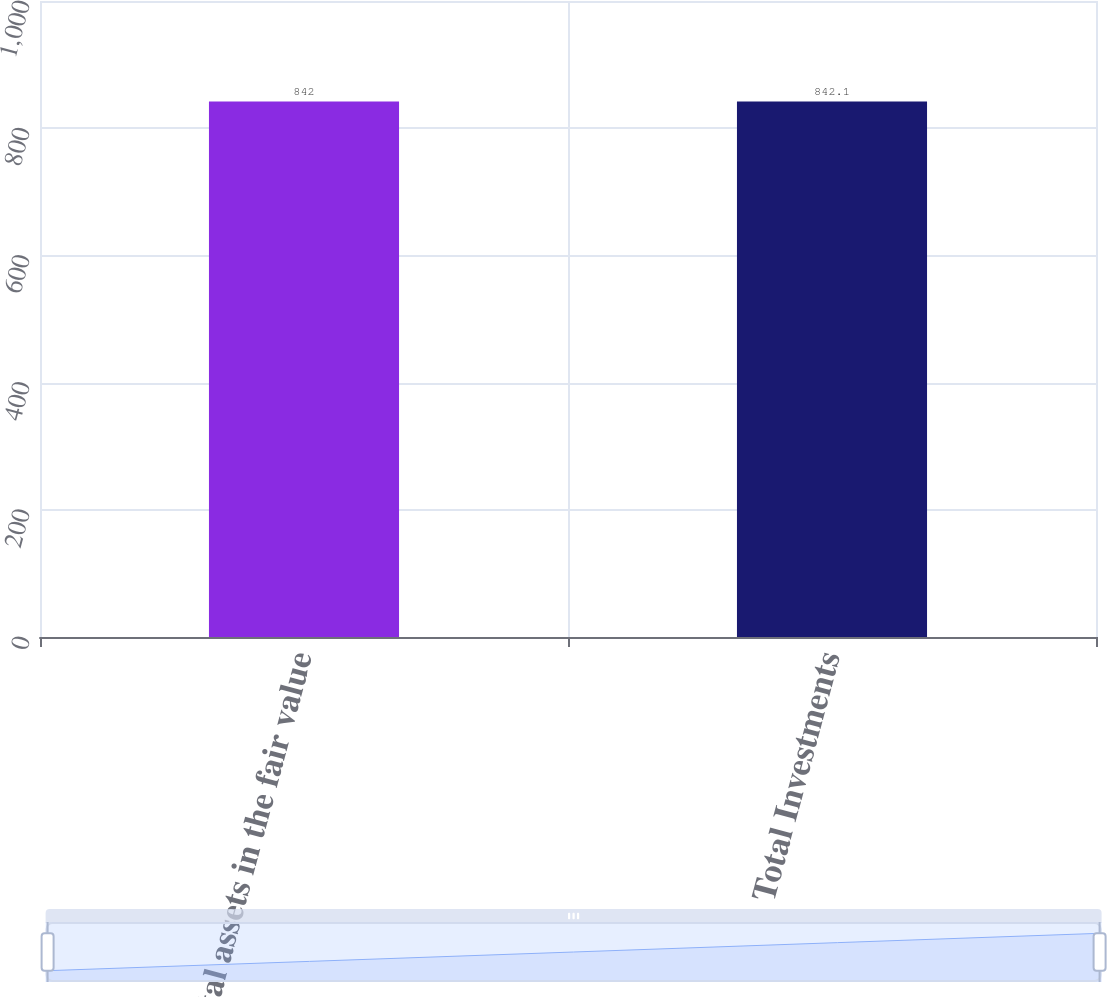Convert chart. <chart><loc_0><loc_0><loc_500><loc_500><bar_chart><fcel>Total assets in the fair value<fcel>Total Investments<nl><fcel>842<fcel>842.1<nl></chart> 